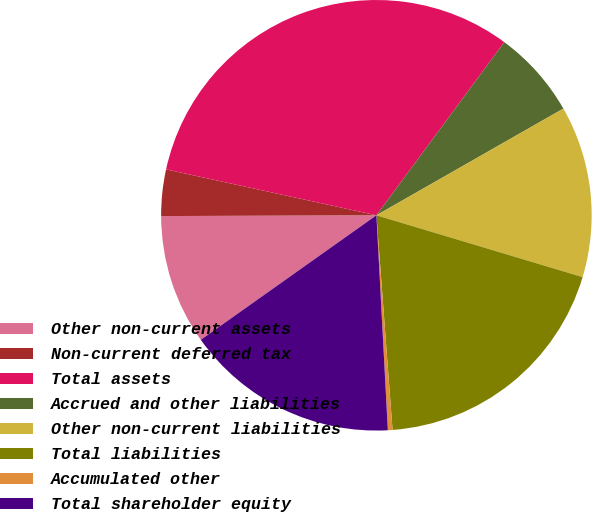<chart> <loc_0><loc_0><loc_500><loc_500><pie_chart><fcel>Other non-current assets<fcel>Non-current deferred tax<fcel>Total assets<fcel>Accrued and other liabilities<fcel>Other non-current liabilities<fcel>Total liabilities<fcel>Accumulated other<fcel>Total shareholder equity<nl><fcel>9.76%<fcel>3.48%<fcel>31.71%<fcel>6.62%<fcel>12.89%<fcel>19.17%<fcel>0.35%<fcel>16.03%<nl></chart> 